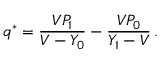<formula> <loc_0><loc_0><loc_500><loc_500>q ^ { * } = \frac { V P _ { 1 } } { V - Y _ { 0 } } - \frac { V P _ { 0 } } { Y _ { 1 } - V } \, .</formula> 